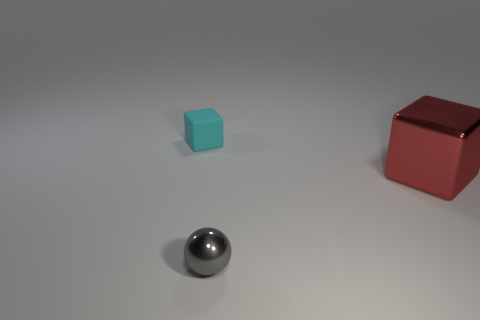Add 1 small gray spheres. How many objects exist? 4 Subtract all cyan blocks. How many blocks are left? 1 Subtract all cubes. How many objects are left? 1 Add 2 tiny matte things. How many tiny matte things are left? 3 Add 3 purple metal cylinders. How many purple metal cylinders exist? 3 Subtract 0 red cylinders. How many objects are left? 3 Subtract all red balls. Subtract all yellow cylinders. How many balls are left? 1 Subtract all purple cylinders. Subtract all small gray metal things. How many objects are left? 2 